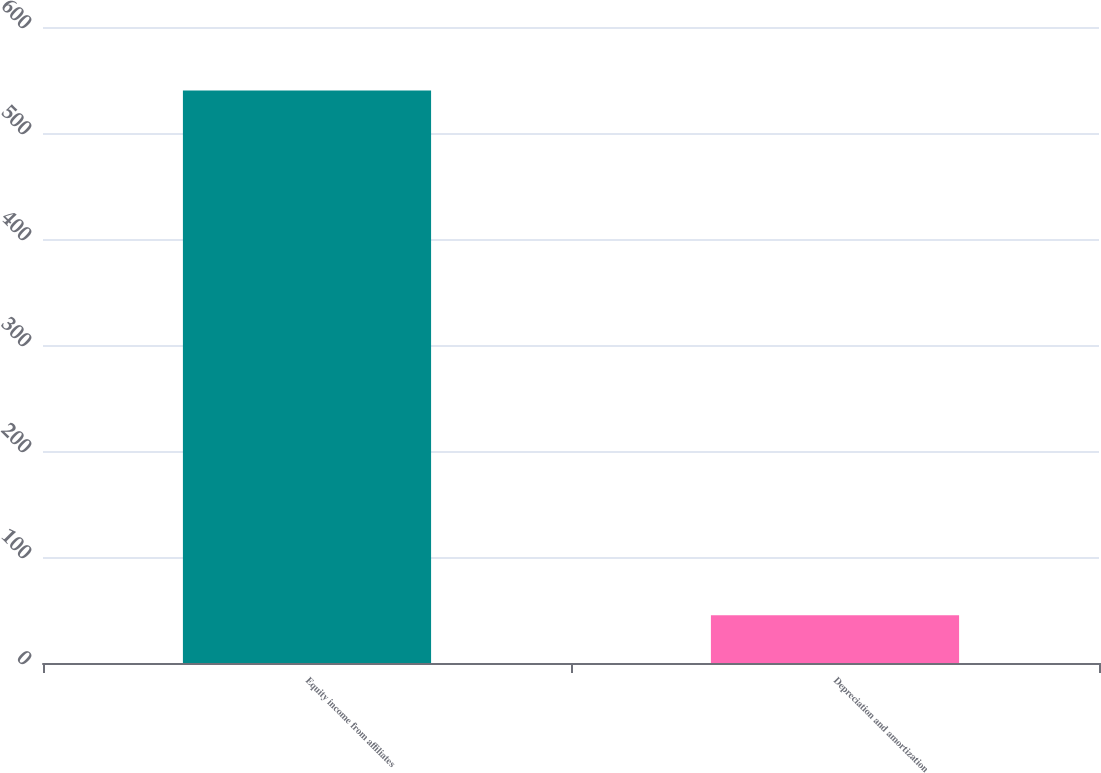Convert chart. <chart><loc_0><loc_0><loc_500><loc_500><bar_chart><fcel>Equity income from affiliates<fcel>Depreciation and amortization<nl><fcel>540<fcel>45<nl></chart> 